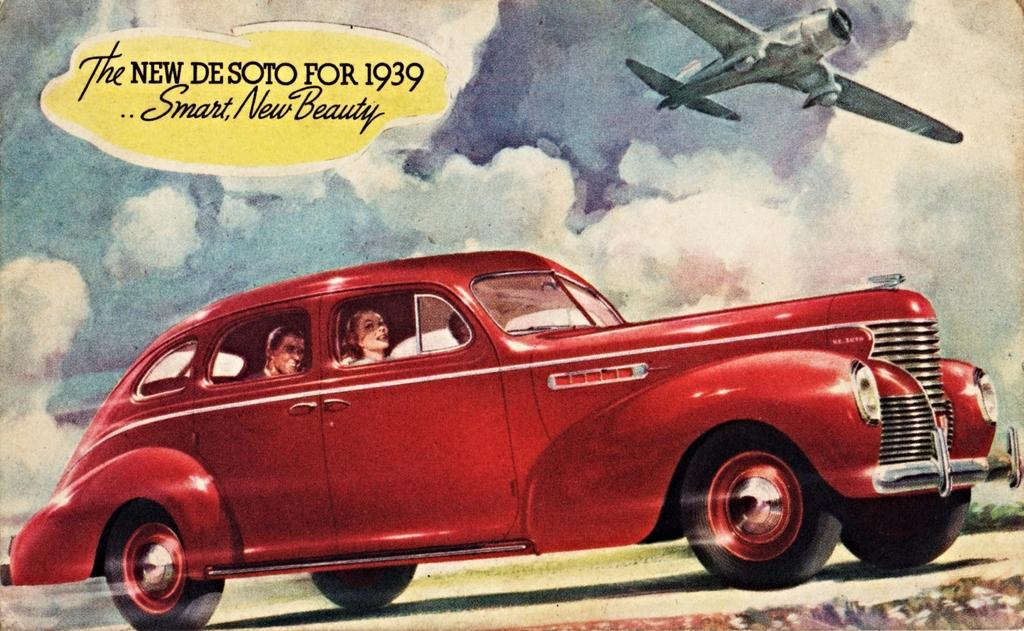What is happening in the image involving people? There are people in a car in the image. What can be seen on the left side of the image? There is text on the left side of the image. What is in the sky in the image? There is an aircraft in the sky. How would you describe the sky in the image? The sky is cloudy. What type of stamp can be seen on the car in the image? There is no stamp present on the car in the image. How many engines are visible on the aircraft in the image? The image does not show the aircraft's engines, so it is not possible to determine the number of engines. 